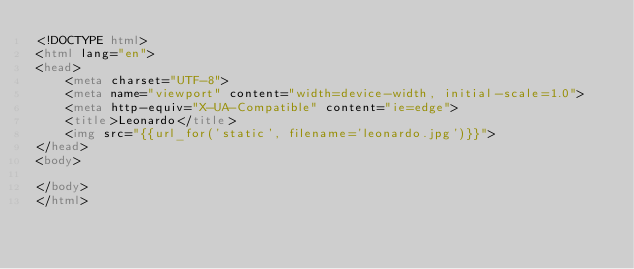<code> <loc_0><loc_0><loc_500><loc_500><_HTML_><!DOCTYPE html>
<html lang="en">
<head>
    <meta charset="UTF-8">
    <meta name="viewport" content="width=device-width, initial-scale=1.0">
    <meta http-equiv="X-UA-Compatible" content="ie=edge">
    <title>Leonardo</title>
    <img src="{{url_for('static', filename='leonardo.jpg')}}">
</head>
<body>
    
</body>
</html></code> 